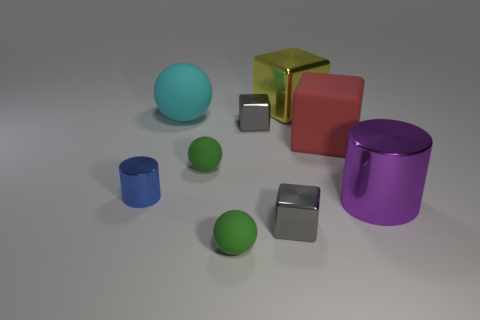Subtract all tiny green spheres. How many spheres are left? 1 Subtract 2 balls. How many balls are left? 1 Add 4 large cyan matte things. How many large cyan matte things exist? 5 Add 1 large red blocks. How many objects exist? 10 Subtract all purple cylinders. How many cylinders are left? 1 Subtract 0 brown cylinders. How many objects are left? 9 Subtract all spheres. How many objects are left? 6 Subtract all red cylinders. Subtract all gray cubes. How many cylinders are left? 2 Subtract all green cubes. How many blue spheres are left? 0 Subtract all large purple metal things. Subtract all tiny gray shiny blocks. How many objects are left? 6 